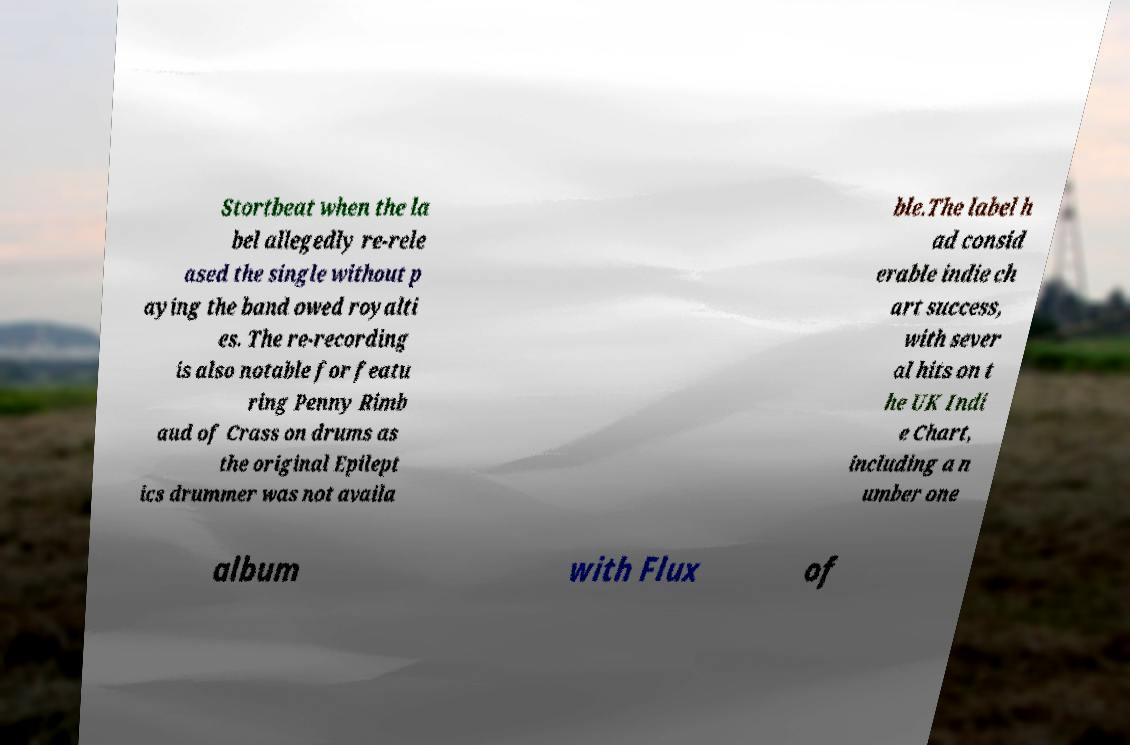There's text embedded in this image that I need extracted. Can you transcribe it verbatim? Stortbeat when the la bel allegedly re-rele ased the single without p aying the band owed royalti es. The re-recording is also notable for featu ring Penny Rimb aud of Crass on drums as the original Epilept ics drummer was not availa ble.The label h ad consid erable indie ch art success, with sever al hits on t he UK Indi e Chart, including a n umber one album with Flux of 